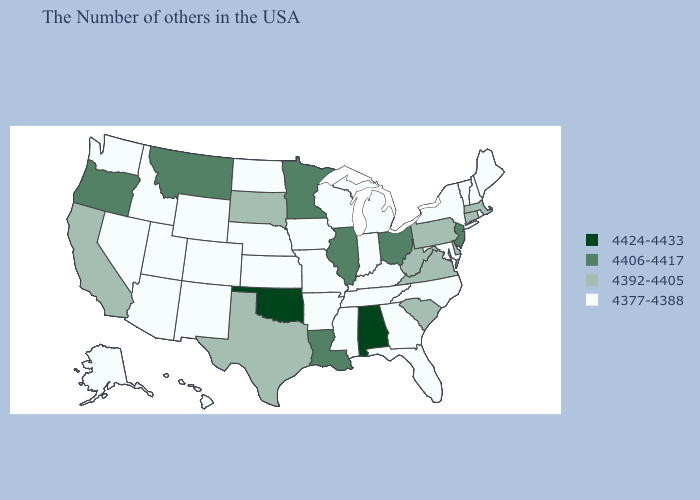What is the value of New Jersey?
Be succinct. 4406-4417. Does Tennessee have a higher value than New Hampshire?
Short answer required. No. Name the states that have a value in the range 4406-4417?
Concise answer only. New Jersey, Ohio, Illinois, Louisiana, Minnesota, Montana, Oregon. Does the map have missing data?
Write a very short answer. No. Which states have the highest value in the USA?
Keep it brief. Alabama, Oklahoma. What is the value of Delaware?
Be succinct. 4392-4405. What is the value of Idaho?
Be succinct. 4377-4388. Which states hav the highest value in the West?
Concise answer only. Montana, Oregon. Among the states that border New Jersey , which have the highest value?
Write a very short answer. Delaware, Pennsylvania. What is the value of Maine?
Keep it brief. 4377-4388. What is the lowest value in states that border Texas?
Give a very brief answer. 4377-4388. Name the states that have a value in the range 4377-4388?
Be succinct. Maine, Rhode Island, New Hampshire, Vermont, New York, Maryland, North Carolina, Florida, Georgia, Michigan, Kentucky, Indiana, Tennessee, Wisconsin, Mississippi, Missouri, Arkansas, Iowa, Kansas, Nebraska, North Dakota, Wyoming, Colorado, New Mexico, Utah, Arizona, Idaho, Nevada, Washington, Alaska, Hawaii. Is the legend a continuous bar?
Quick response, please. No. What is the lowest value in states that border Virginia?
Answer briefly. 4377-4388. 